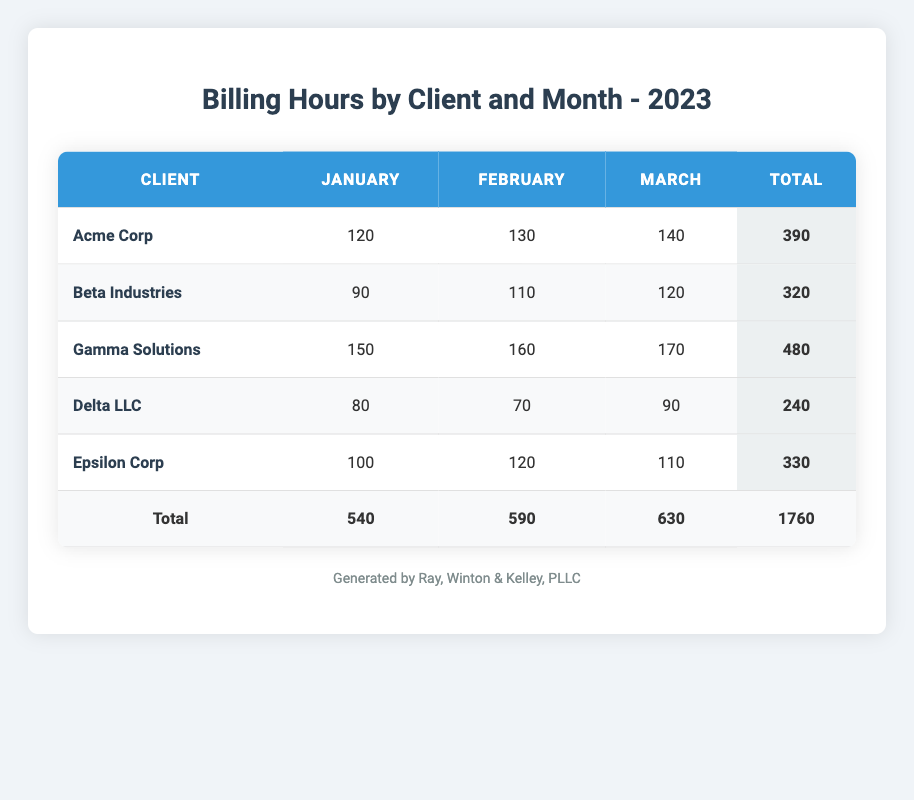What is the total number of billing hours for Acme Corp in January? Acme Corp's billing hours for January is explicitly listed in the table as 120.
Answer: 120 How many billing hours did Beta Industries record in February? The table indicates that Beta Industries billed 110 hours in February.
Answer: 110 Which client recorded the highest total billing hours across all months? By summing up all the hours for each client: Acme Corp (390), Beta Industries (320), Gamma Solutions (480), Delta LLC (240), and Epsilon Corp (330). Gamma Solutions has the highest total of 480 hours.
Answer: Gamma Solutions What is the average billing hours for Delta LLC across the three months? Delta LLC's billing for the three months are 80 (January), 70 (February), and 90 (March). The total is 80 + 70 + 90 = 240. The average is 240 / 3 = 80.
Answer: 80 Did Epsilon Corp have more billing hours in March than in January? Epsilon Corp's billing hours in March is 110, which is more than the 100 hours billed in January.
Answer: Yes What are the total billing hours for all clients in February? Adding the hours for February: Acme Corp (130), Beta Industries (110), Gamma Solutions (160), Delta LLC (70), and Epsilon Corp (120). Thus, the total is 130 + 110 + 160 + 70 + 120 = 590 hours.
Answer: 590 Which client had the smallest total billing hours in the three months? Calculating total hours: Acme Corp (390), Beta Industries (320), Gamma Solutions (480), Delta LLC (240), and Epsilon Corp (330). Delta LLC had the smallest total at 240 hours.
Answer: Delta LLC How many more hours did Gamma Solutions record in February than in January? Gamma Solutions billed 160 hours in February and 150 hours in January. The difference is 160 - 150 = 10 hours more in February.
Answer: 10 Is it true that all clients billed more hours in March compared to January? Assessing the data: Acme Corp (120 in January vs 140 in March), Beta Industries (90 vs 120), Gamma Solutions (150 vs 170), Delta LLC (80 vs 90), and Epsilon Corp (100 vs 110). All clients did indeed bill more hours in March compared to January.
Answer: Yes 